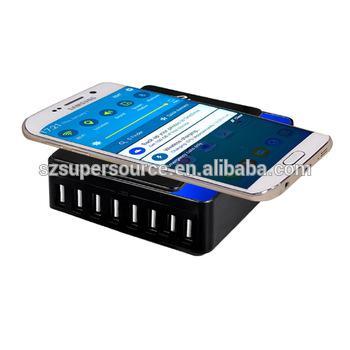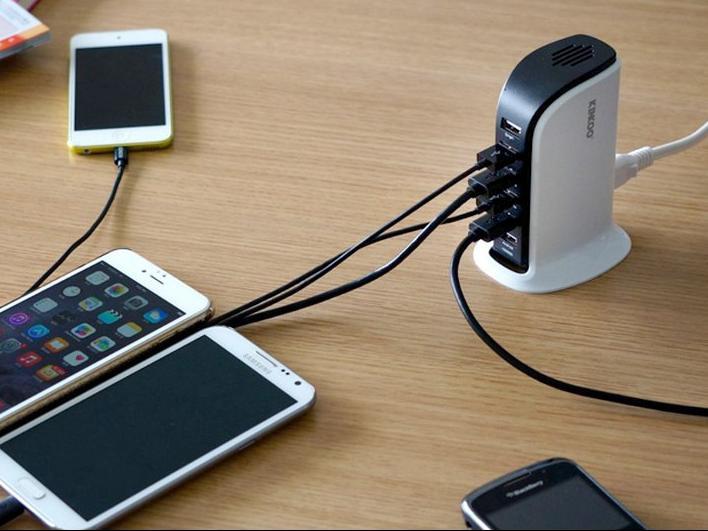The first image is the image on the left, the second image is the image on the right. Analyze the images presented: Is the assertion "The devices in the left image are plugged into a black colored charging station." valid? Answer yes or no. No. The first image is the image on the left, the second image is the image on the right. Examine the images to the left and right. Is the description "An image shows an upright charging station with one white cord in the back and several cords all of one color in the front, with multiple screened devices lying flat nearby it on a wood-grain surface." accurate? Answer yes or no. Yes. 